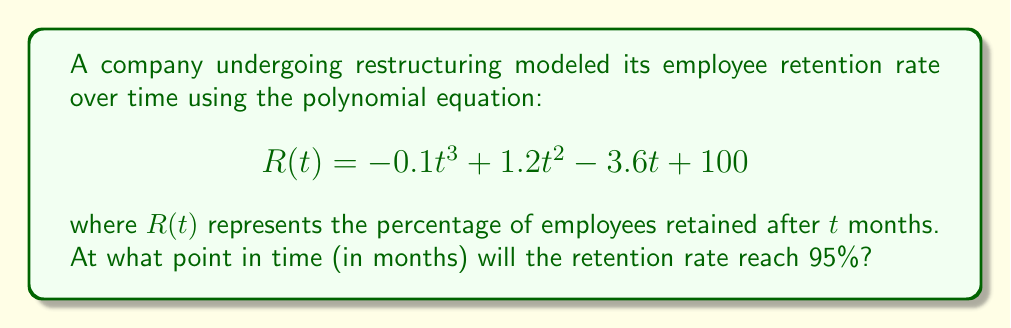Give your solution to this math problem. To solve this problem, we need to find the value of $t$ when $R(t) = 95$. Let's approach this step-by-step:

1) Set up the equation:
   $$-0.1t^3 + 1.2t^2 - 3.6t + 100 = 95$$

2) Rearrange the equation to standard form:
   $$-0.1t^3 + 1.2t^2 - 3.6t + 5 = 0$$

3) This is a cubic equation. We can solve it by factoring. Let's try to guess one factor first. By inspection, we can see that $t = 1$ is a solution (plug it in to verify).

4) Divide the polynomial by $(t - 1)$ using polynomial long division:
   $$-0.1t^3 + 1.2t^2 - 3.6t + 5 = (t - 1)(-0.1t^2 + 1.1t - 5)$$

5) Now we have a quadratic equation to solve: $-0.1t^2 + 1.1t - 5 = 0$

6) Use the quadratic formula: $t = \frac{-b \pm \sqrt{b^2 - 4ac}}{2a}$
   Where $a = -0.1$, $b = 1.1$, and $c = -5$

7) Plugging in these values:
   $$t = \frac{-1.1 \pm \sqrt{1.1^2 - 4(-0.1)(-5)}}{2(-0.1)}$$
   $$= \frac{-1.1 \pm \sqrt{1.21 - 2}}{-0.2}$$
   $$= \frac{-1.1 \pm \sqrt{-0.79}}{-0.2}$$

8) Since the square root of a negative number gives imaginary solutions, these are not relevant to our real-world problem.

Therefore, the only real solution is $t = 1$.
Answer: 1 month 